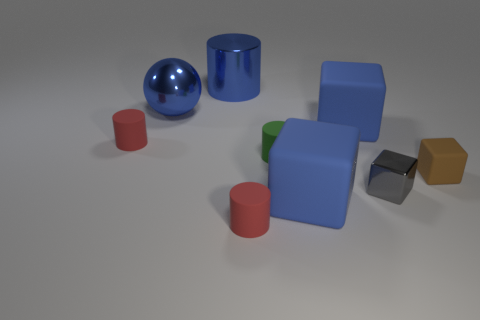Subtract all gray blocks. How many blocks are left? 3 Subtract all brown blocks. How many blocks are left? 3 Subtract 1 cylinders. How many cylinders are left? 3 Add 1 big blue shiny cylinders. How many objects exist? 10 Subtract all green blocks. Subtract all brown spheres. How many blocks are left? 4 Subtract all cylinders. How many objects are left? 5 Subtract all big blue rubber things. Subtract all tiny gray blocks. How many objects are left? 6 Add 3 tiny red rubber cylinders. How many tiny red rubber cylinders are left? 5 Add 7 small red rubber cubes. How many small red rubber cubes exist? 7 Subtract 0 yellow balls. How many objects are left? 9 